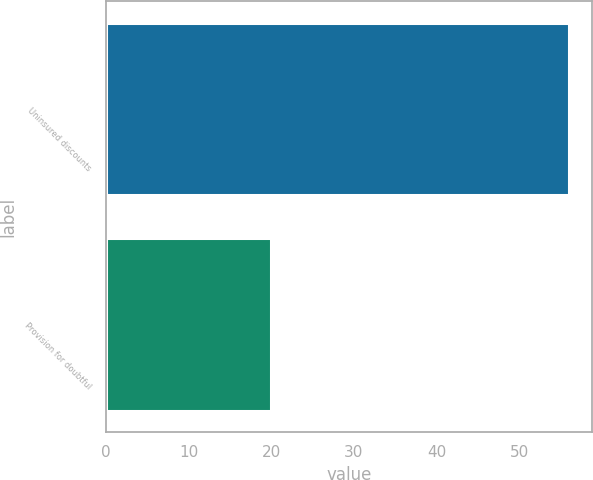<chart> <loc_0><loc_0><loc_500><loc_500><bar_chart><fcel>Uninsured discounts<fcel>Provision for doubtful<nl><fcel>56<fcel>20<nl></chart> 